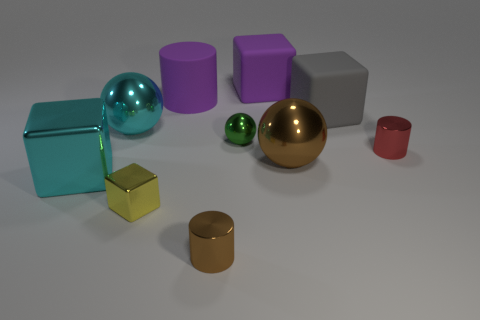If these objects were part of a set, what could they represent? If they were part of a set, these objects might represent a collection of geometrical shapes meant for educational purposes, demonstrating various sizes, colors, and shapes, such as cubes, cylinders, and spheres. 